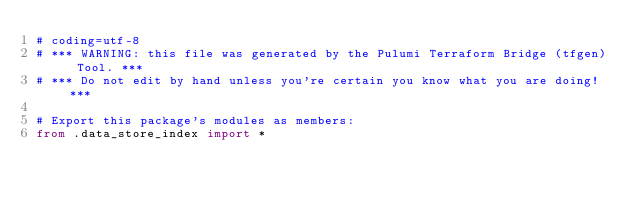<code> <loc_0><loc_0><loc_500><loc_500><_Python_># coding=utf-8
# *** WARNING: this file was generated by the Pulumi Terraform Bridge (tfgen) Tool. ***
# *** Do not edit by hand unless you're certain you know what you are doing! ***

# Export this package's modules as members:
from .data_store_index import *
</code> 